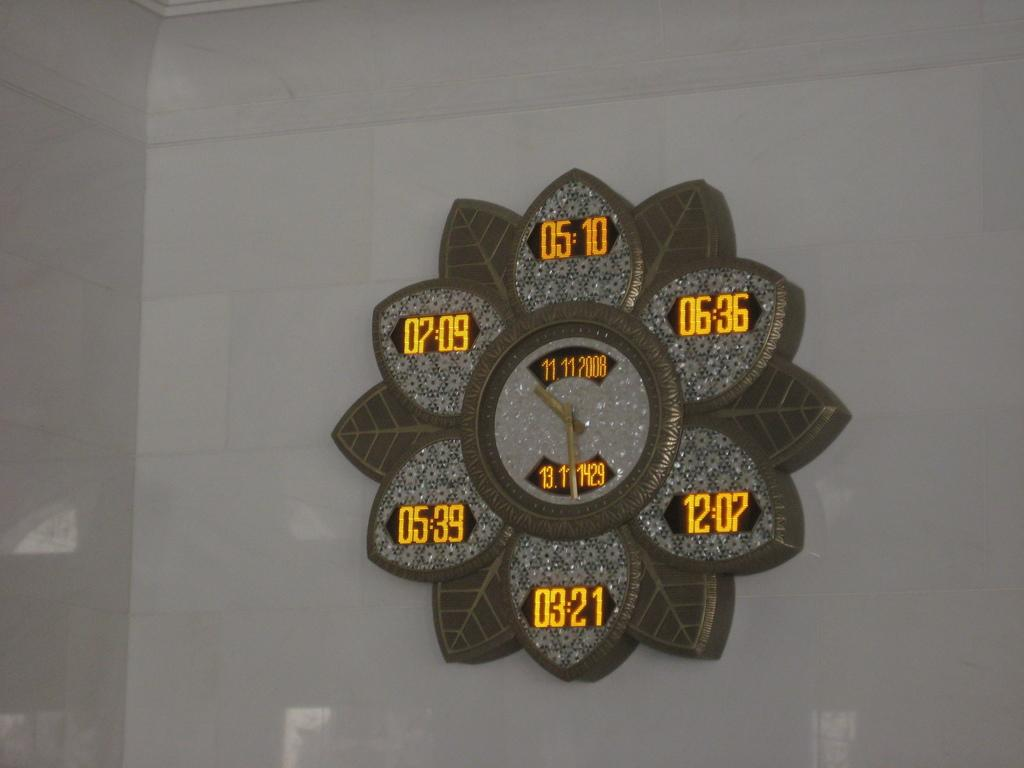What object in the image tells the time? There is a clock in the image that tells the time. Where is the clock located in the image? The clock is attached to a white-colored wall. What type of cloth is draped over the family in the image? There is no family or cloth present in the image; it only features a clock attached to a white-colored wall. 